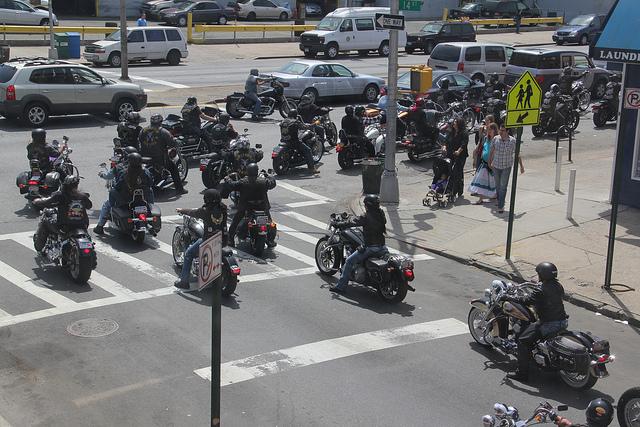Are the motorcyclists turning right or left?
Write a very short answer. Right. What is causing traffic?
Concise answer only. Motorcycles. What is on the sign?
Keep it brief. People. 